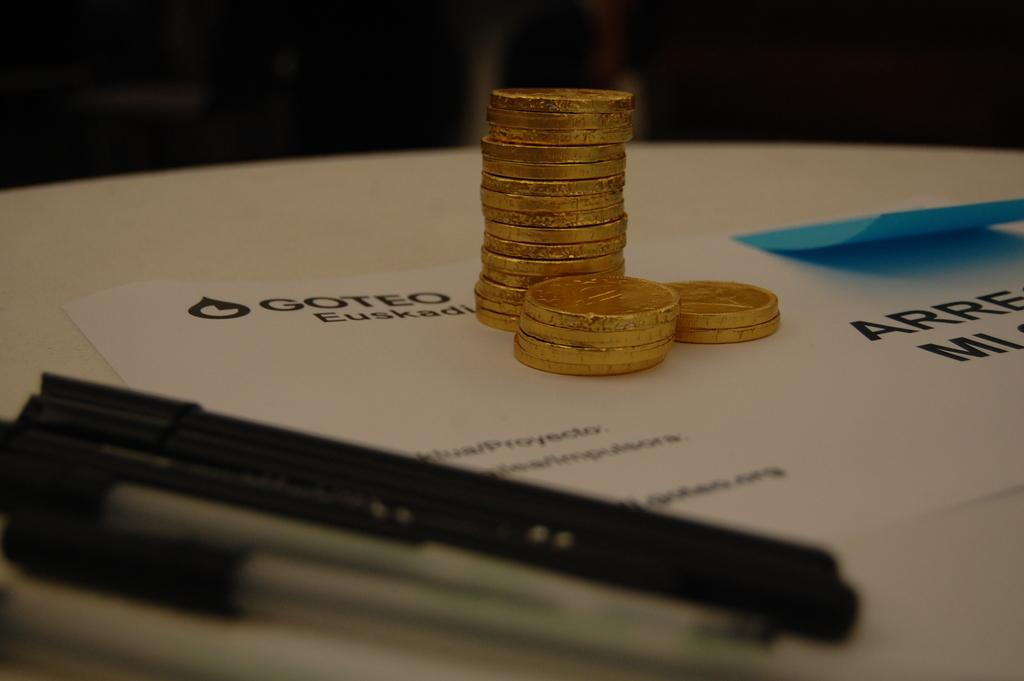<image>
Create a compact narrative representing the image presented. Some coins and ink pens sit on a piece of paper labeled "Goteo." 